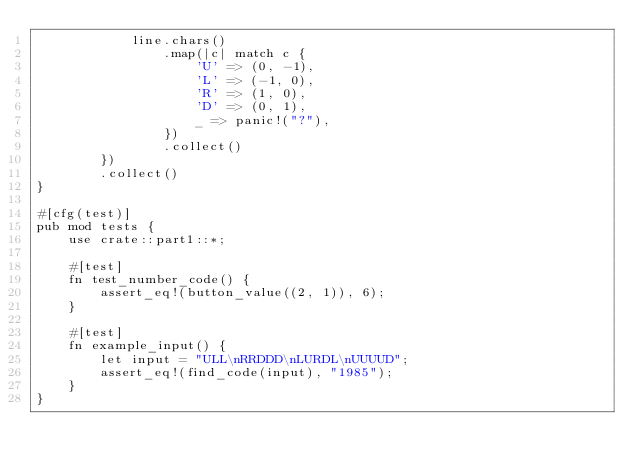Convert code to text. <code><loc_0><loc_0><loc_500><loc_500><_Rust_>            line.chars()
                .map(|c| match c {
                    'U' => (0, -1),
                    'L' => (-1, 0),
                    'R' => (1, 0),
                    'D' => (0, 1),
                    _ => panic!("?"),
                })
                .collect()
        })
        .collect()
}

#[cfg(test)]
pub mod tests {
    use crate::part1::*;

    #[test]
    fn test_number_code() {
        assert_eq!(button_value((2, 1)), 6);
    }

    #[test]
    fn example_input() {
        let input = "ULL\nRRDDD\nLURDL\nUUUUD";
        assert_eq!(find_code(input), "1985");
    }
}
</code> 